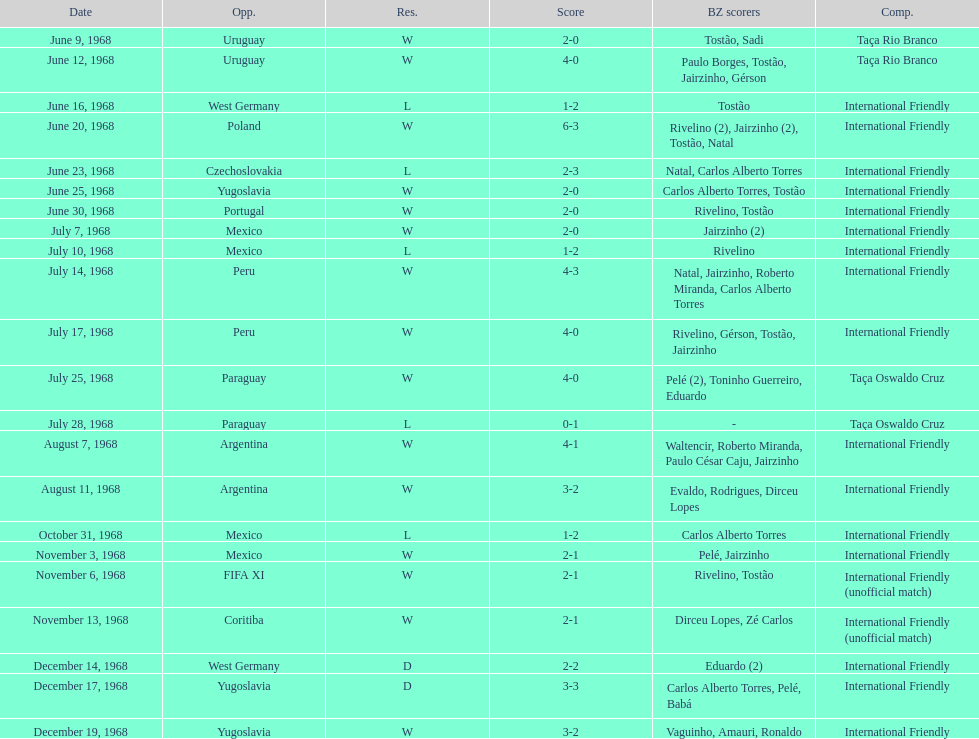What year has the highest scoring game? 1968. Help me parse the entirety of this table. {'header': ['Date', 'Opp.', 'Res.', 'Score', 'BZ scorers', 'Comp.'], 'rows': [['June 9, 1968', 'Uruguay', 'W', '2-0', 'Tostão, Sadi', 'Taça Rio Branco'], ['June 12, 1968', 'Uruguay', 'W', '4-0', 'Paulo Borges, Tostão, Jairzinho, Gérson', 'Taça Rio Branco'], ['June 16, 1968', 'West Germany', 'L', '1-2', 'Tostão', 'International Friendly'], ['June 20, 1968', 'Poland', 'W', '6-3', 'Rivelino (2), Jairzinho (2), Tostão, Natal', 'International Friendly'], ['June 23, 1968', 'Czechoslovakia', 'L', '2-3', 'Natal, Carlos Alberto Torres', 'International Friendly'], ['June 25, 1968', 'Yugoslavia', 'W', '2-0', 'Carlos Alberto Torres, Tostão', 'International Friendly'], ['June 30, 1968', 'Portugal', 'W', '2-0', 'Rivelino, Tostão', 'International Friendly'], ['July 7, 1968', 'Mexico', 'W', '2-0', 'Jairzinho (2)', 'International Friendly'], ['July 10, 1968', 'Mexico', 'L', '1-2', 'Rivelino', 'International Friendly'], ['July 14, 1968', 'Peru', 'W', '4-3', 'Natal, Jairzinho, Roberto Miranda, Carlos Alberto Torres', 'International Friendly'], ['July 17, 1968', 'Peru', 'W', '4-0', 'Rivelino, Gérson, Tostão, Jairzinho', 'International Friendly'], ['July 25, 1968', 'Paraguay', 'W', '4-0', 'Pelé (2), Toninho Guerreiro, Eduardo', 'Taça Oswaldo Cruz'], ['July 28, 1968', 'Paraguay', 'L', '0-1', '-', 'Taça Oswaldo Cruz'], ['August 7, 1968', 'Argentina', 'W', '4-1', 'Waltencir, Roberto Miranda, Paulo César Caju, Jairzinho', 'International Friendly'], ['August 11, 1968', 'Argentina', 'W', '3-2', 'Evaldo, Rodrigues, Dirceu Lopes', 'International Friendly'], ['October 31, 1968', 'Mexico', 'L', '1-2', 'Carlos Alberto Torres', 'International Friendly'], ['November 3, 1968', 'Mexico', 'W', '2-1', 'Pelé, Jairzinho', 'International Friendly'], ['November 6, 1968', 'FIFA XI', 'W', '2-1', 'Rivelino, Tostão', 'International Friendly (unofficial match)'], ['November 13, 1968', 'Coritiba', 'W', '2-1', 'Dirceu Lopes, Zé Carlos', 'International Friendly (unofficial match)'], ['December 14, 1968', 'West Germany', 'D', '2-2', 'Eduardo (2)', 'International Friendly'], ['December 17, 1968', 'Yugoslavia', 'D', '3-3', 'Carlos Alberto Torres, Pelé, Babá', 'International Friendly'], ['December 19, 1968', 'Yugoslavia', 'W', '3-2', 'Vaguinho, Amauri, Ronaldo', 'International Friendly']]} 